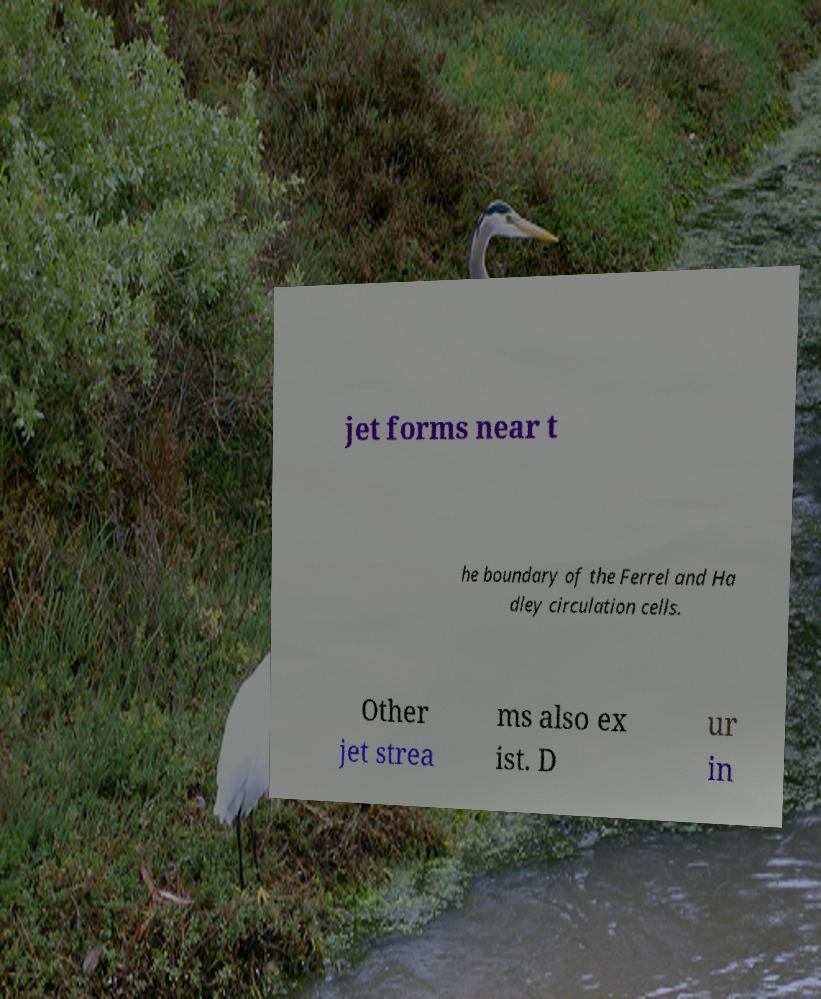Can you accurately transcribe the text from the provided image for me? jet forms near t he boundary of the Ferrel and Ha dley circulation cells. Other jet strea ms also ex ist. D ur in 